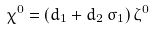<formula> <loc_0><loc_0><loc_500><loc_500>\chi ^ { 0 } = ( d _ { 1 } + d _ { 2 } \, \sigma _ { 1 } ) \, \zeta ^ { 0 }</formula> 